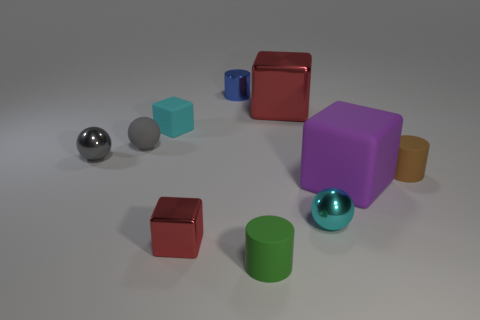How would you describe the overall arrangement of the objects in this image? The objects in the image are thoughtfully arranged with a balance of colors and shapes. They are spaced out across a flat surface, suggesting an intentional layout possibly for a visual composition or an abstract collection. 